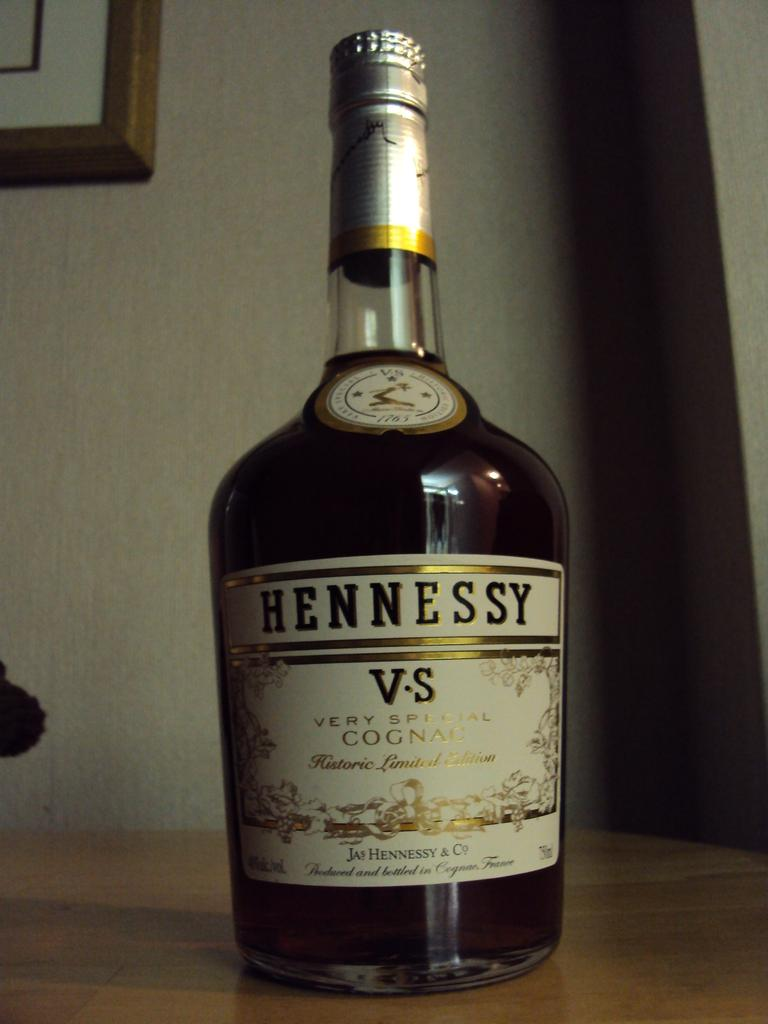What object can be seen in the image? There is a bottle in the image. What feature does the bottle have? The bottle has a label. What information is on the label? The label contains text. What can be seen in the background of the image? There is a wall in the background of the image. What type of shirt is the beast wearing in the image? There is no beast or shirt present in the image; it only features a bottle with a label and a wall in the background. 